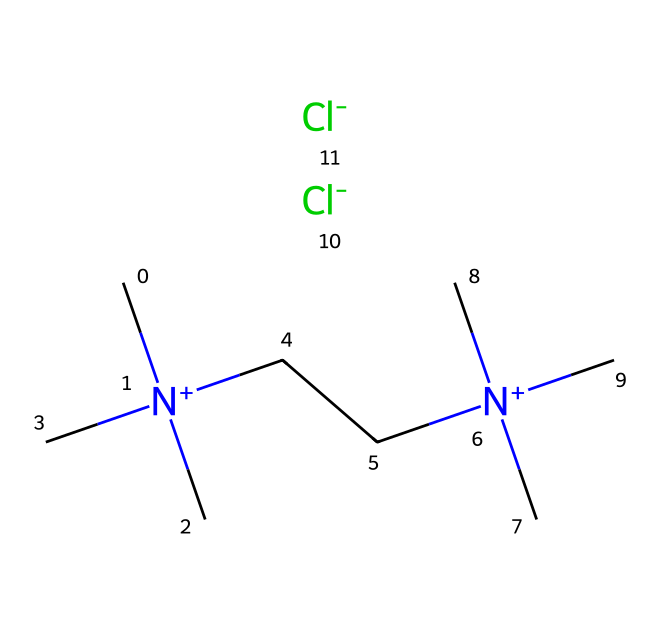How many nitrogen atoms are present in the ionic liquid? The SMILES representation indicates two nitrogen atoms are present, as denoted by the bracketed [N+] symbols and the presence of two distinct regions indicating nitrogen's attachment.
Answer: two What is the anion in this ionic liquid structure? The presence of [Cl-] in the SMILES indicates that chlorine serves as the anion, which is standard for ionic liquids.
Answer: chloride How many carbon atoms are present in the molecular structure? By analyzing the SMILES notation, there are a total of 14 carbon atoms, as each 'C' represents a carbon and can be counted directly.
Answer: fourteen Is this ionic liquid a symmetric or asymmetric structure? The presence of two identical cations, represented by identical groups on both sides, indicates that it has a symmetric structure.
Answer: symmetric What potential application is suggested by the presence of ionic liquid in drug delivery? Ionic liquids are known for their ability to solubilize and stabilize various pharmaceutical compounds, making them ideal for drug delivery systems.
Answer: drug delivery What is the overall charge of the ionic liquid? The structural formula contains two positively charged nitrogen atoms (indicated by [N+]) and two negatively charged chloride ions, which balance out to an overall neutral charge.
Answer: neutral What type of bonding predominates in this ionic liquid? The ionic bonding is indicated by the presence of [N+] and [Cl-], pointing to strong electrostatic interactions between the cations and anions within the structure.
Answer: ionic 